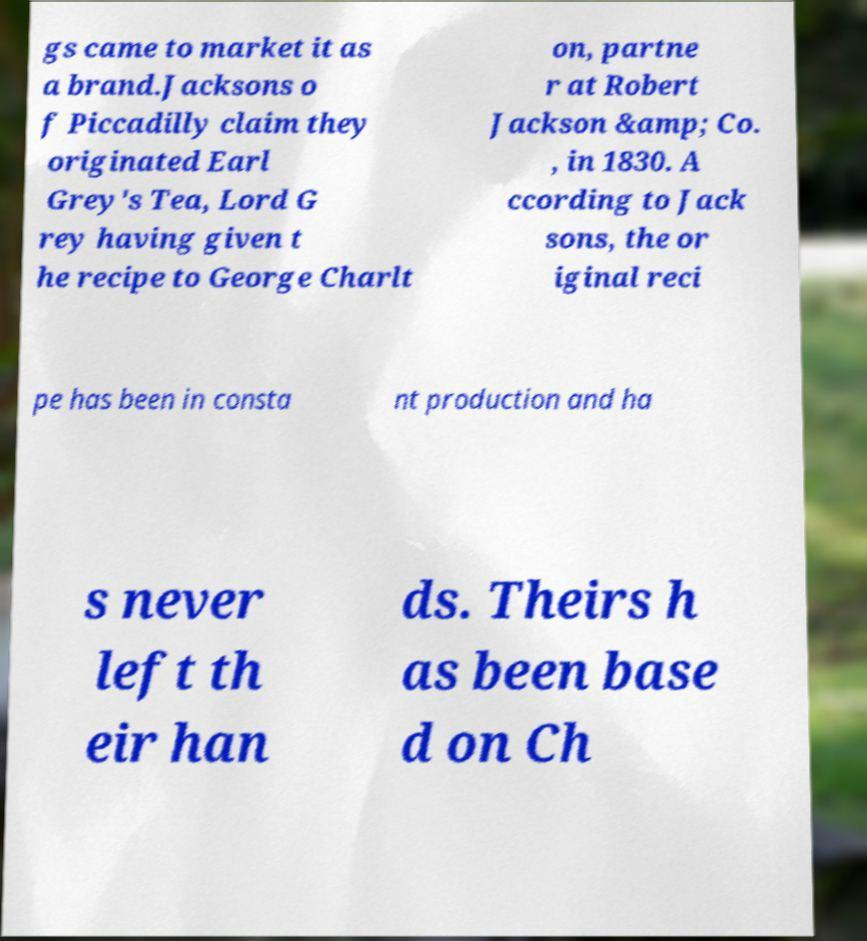Could you extract and type out the text from this image? gs came to market it as a brand.Jacksons o f Piccadilly claim they originated Earl Grey's Tea, Lord G rey having given t he recipe to George Charlt on, partne r at Robert Jackson &amp; Co. , in 1830. A ccording to Jack sons, the or iginal reci pe has been in consta nt production and ha s never left th eir han ds. Theirs h as been base d on Ch 